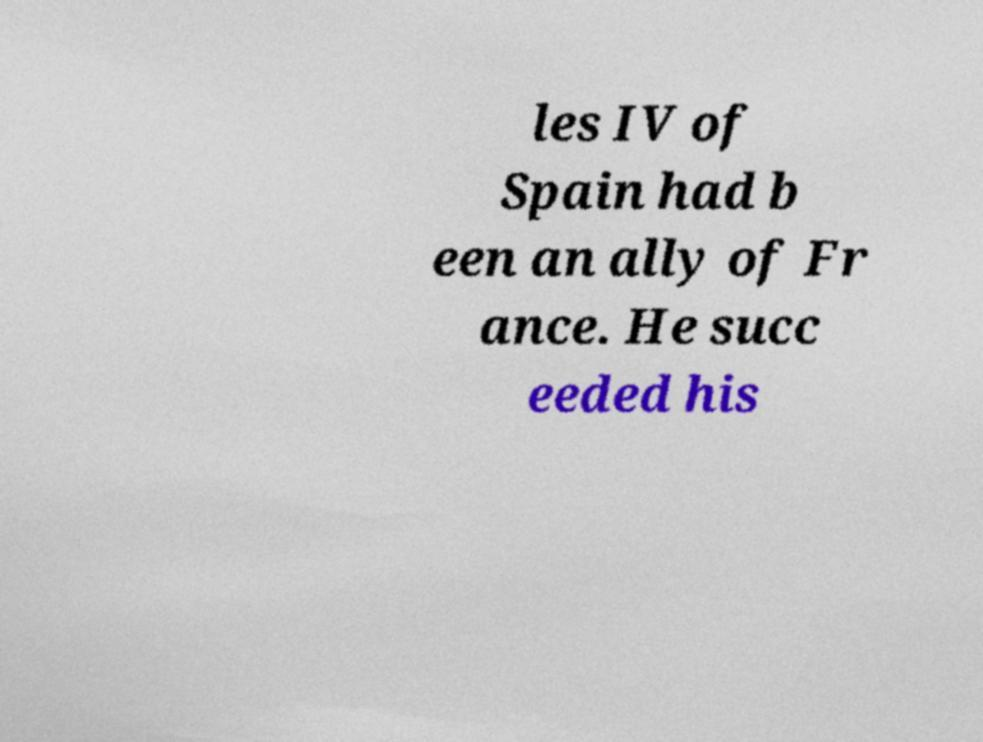Can you read and provide the text displayed in the image?This photo seems to have some interesting text. Can you extract and type it out for me? les IV of Spain had b een an ally of Fr ance. He succ eeded his 